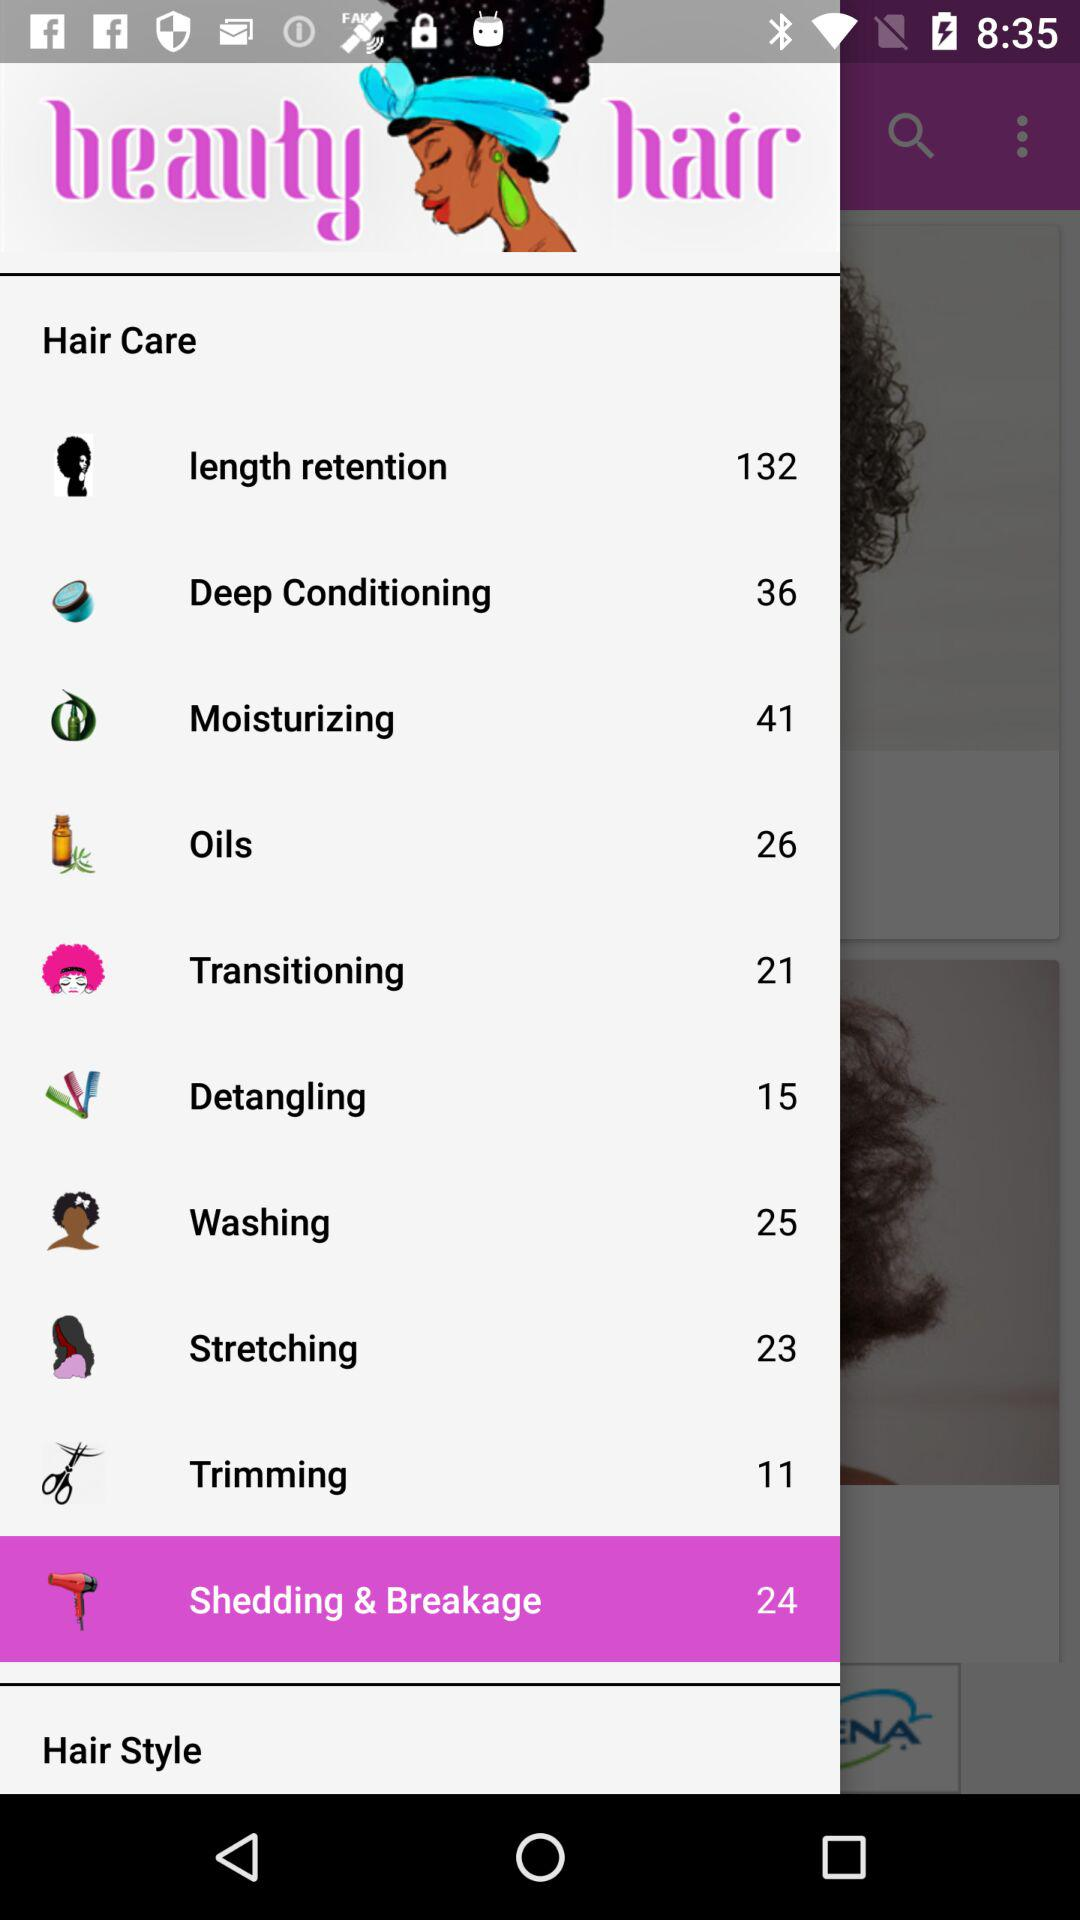What is the count of items in "Trimming"? The count of items is 11. 